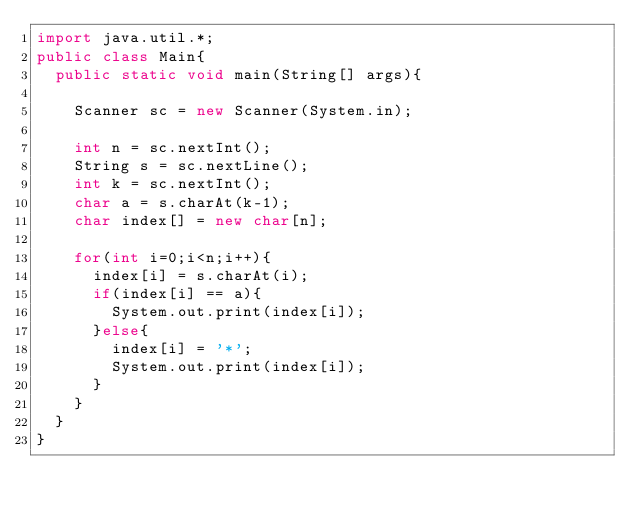Convert code to text. <code><loc_0><loc_0><loc_500><loc_500><_Java_>import java.util.*;
public class Main{
  public static void main(String[] args){
    
    Scanner sc = new Scanner(System.in);
    
    int n = sc.nextInt();
    String s = sc.nextLine();
    int k = sc.nextInt();
    char a = s.charAt(k-1); 
    char index[] = new char[n];
    
    for(int i=0;i<n;i++){
      index[i] = s.charAt(i);
      if(index[i] == a){
        System.out.print(index[i]);
      }else{
        index[i] = '*';
        System.out.print(index[i]);
      }
    }
  }
}   </code> 